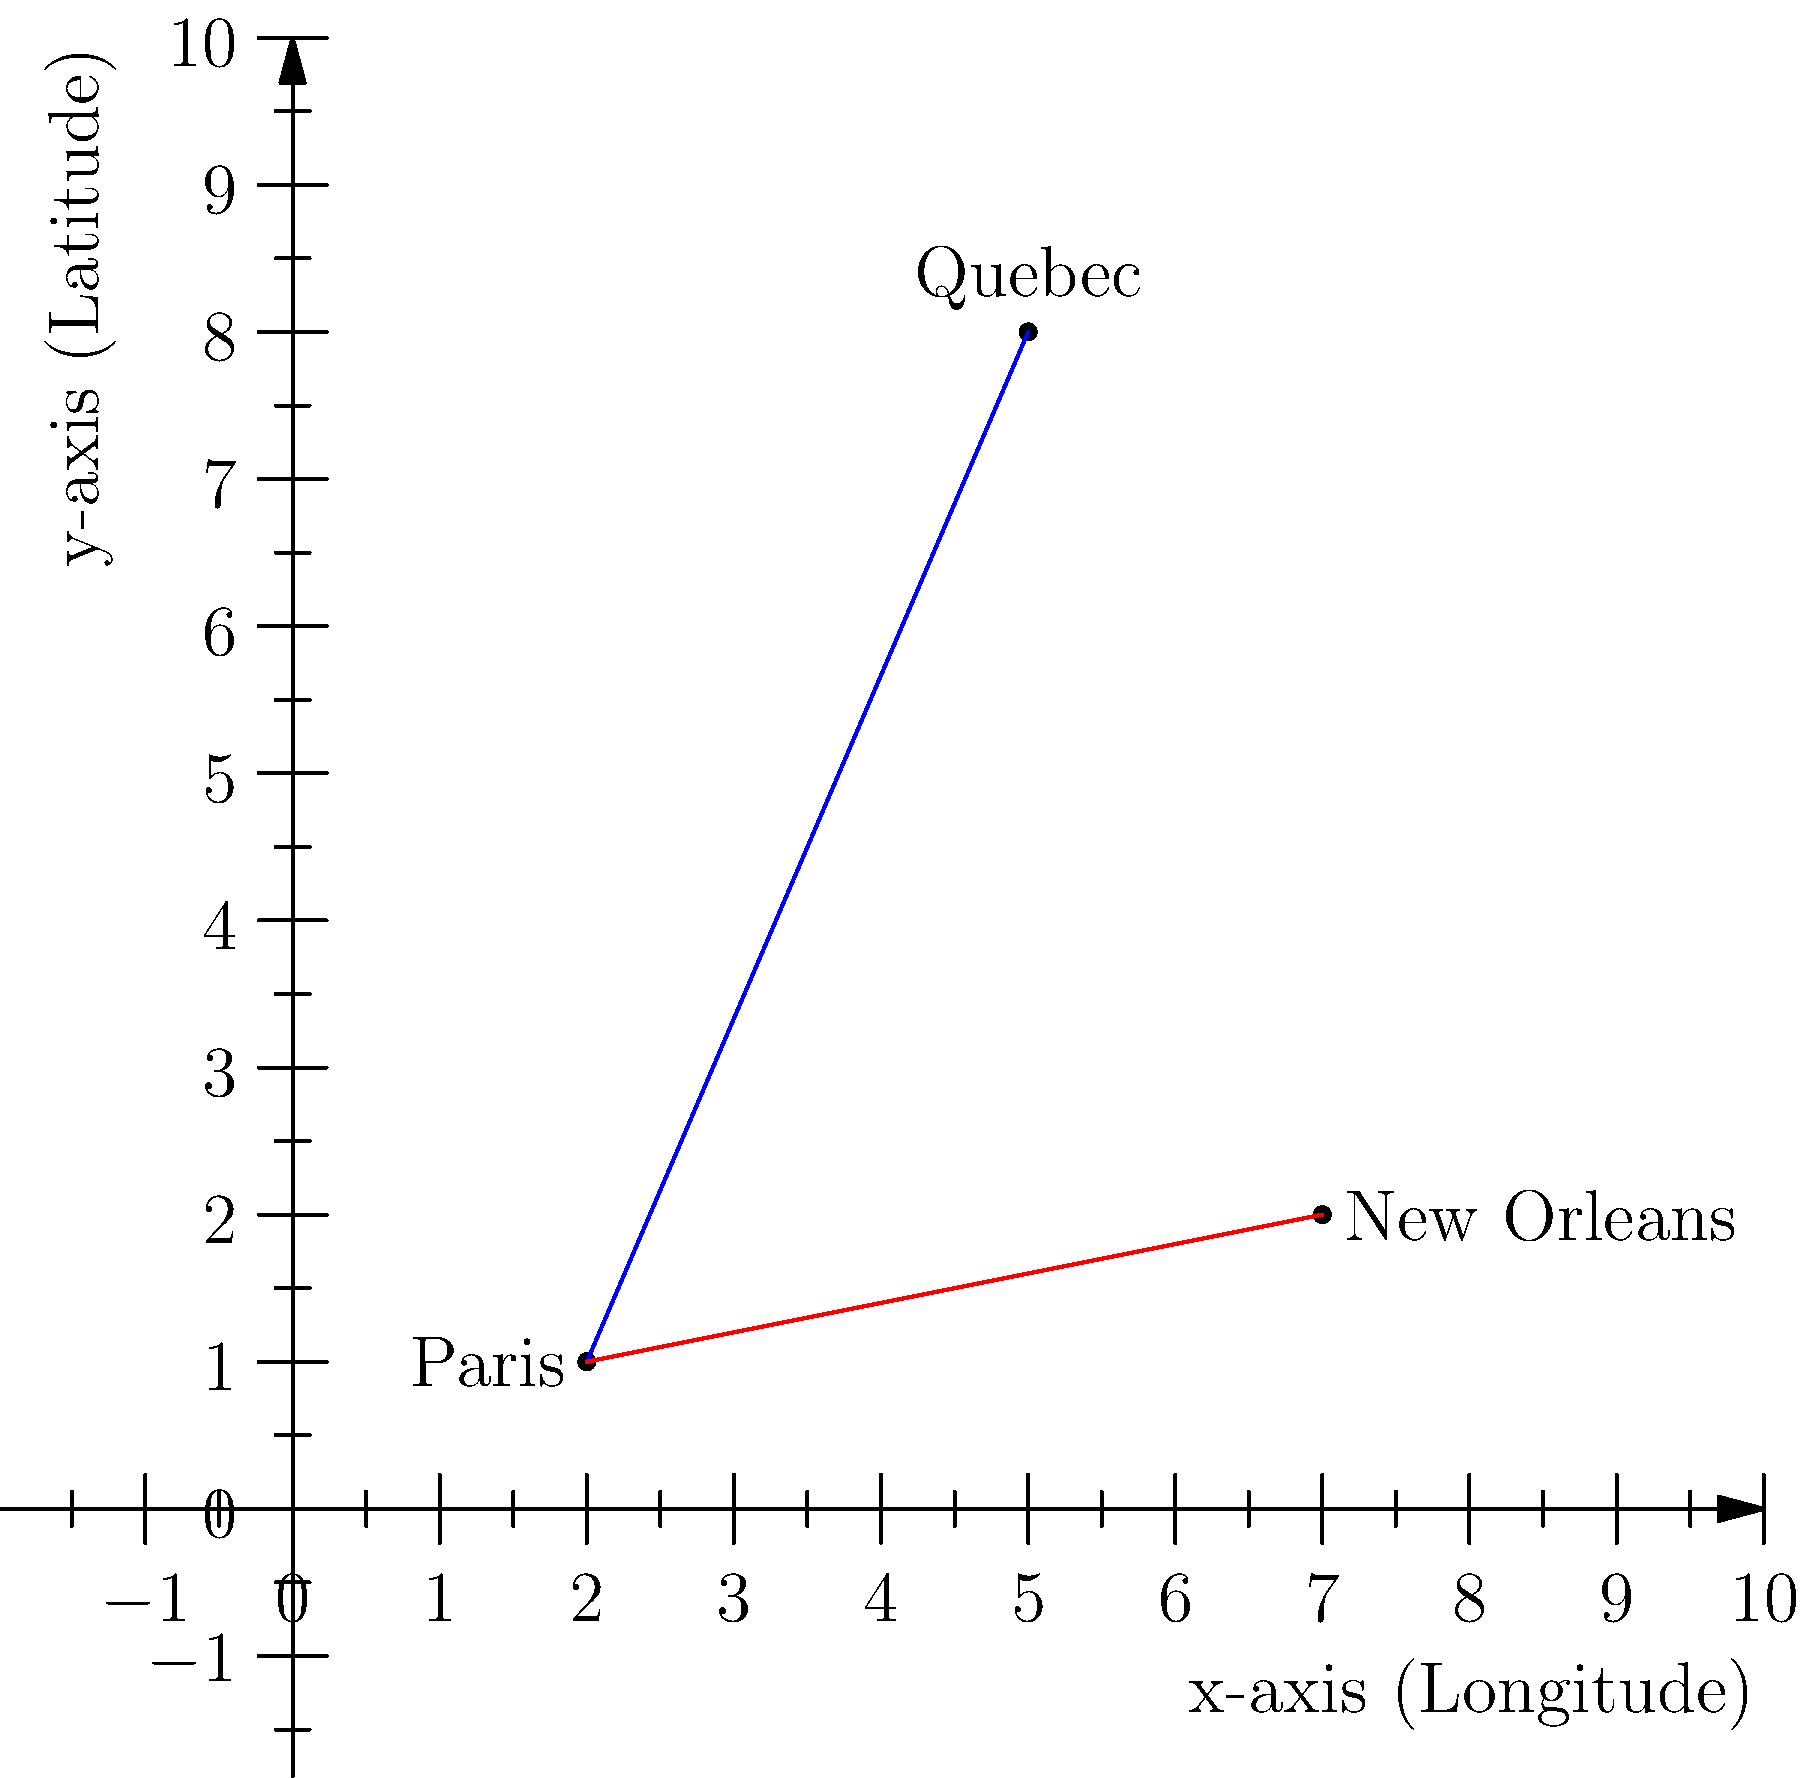On the given coordinate plane representing a simplified map of North America, Paris is located at (2,1), Quebec at (5,8), and New Orleans at (7,2). Two major French immigration routes are shown: the blue line represents the route from Paris to Quebec, and the red line represents the route from Paris to New Orleans. Calculate the total distance traveled by French immigrants who first sailed to Quebec and then traveled south to New Orleans. Round your answer to the nearest whole number. To solve this problem, we need to follow these steps:

1. Calculate the distance from Paris to Quebec:
   Using the distance formula: $d = \sqrt{(x_2-x_1)^2 + (y_2-y_1)^2}$
   $d_{PQ} = \sqrt{(5-2)^2 + (8-1)^2} = \sqrt{3^2 + 7^2} = \sqrt{9 + 49} = \sqrt{58} \approx 7.62$

2. Calculate the distance from Quebec to New Orleans:
   $d_{QN} = \sqrt{(7-5)^2 + (2-8)^2} = \sqrt{2^2 + (-6)^2} = \sqrt{4 + 36} = \sqrt{40} \approx 6.32$

3. Sum up the total distance:
   Total distance = $d_{PQ} + d_{QN} = 7.62 + 6.32 = 13.94$

4. Round to the nearest whole number:
   13.94 rounds to 14

Therefore, the total distance traveled is approximately 14 units on the coordinate plane.
Answer: 14 units 